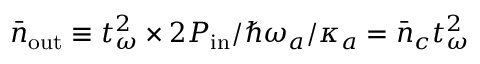<formula> <loc_0><loc_0><loc_500><loc_500>\bar { n } _ { o u t } \equiv t _ { \omega } ^ { 2 } \times 2 P _ { i n } / \hbar { \omega } _ { a } / \kappa _ { a } = \bar { n } _ { c } t _ { \omega } ^ { 2 }</formula> 